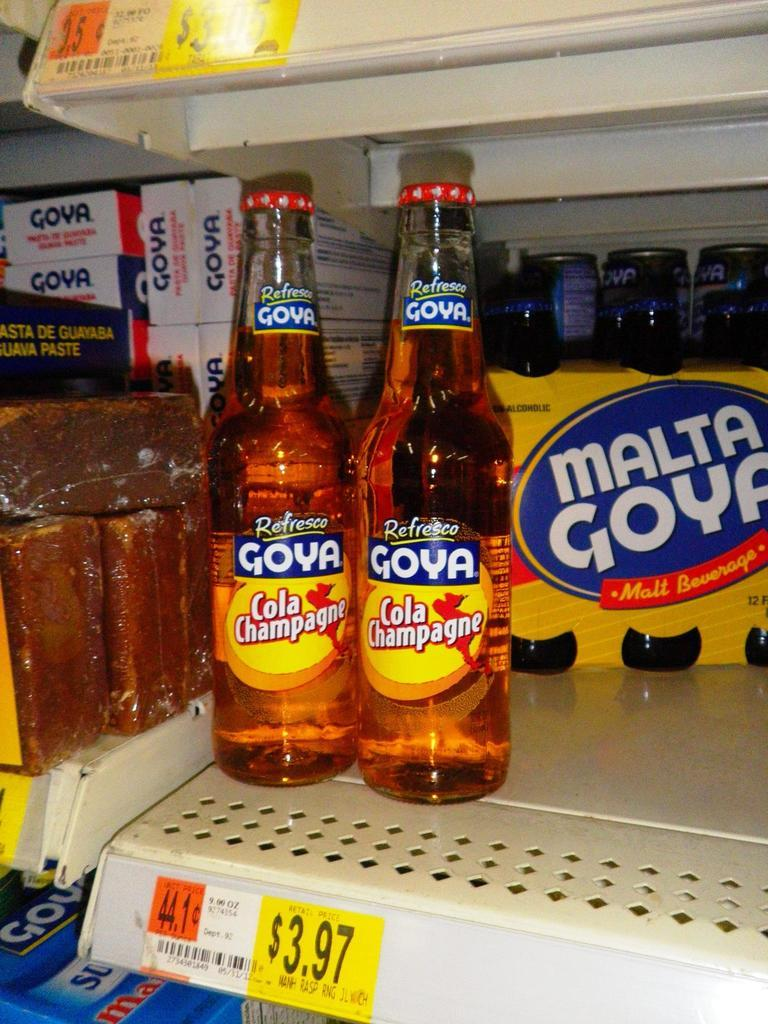Provide a one-sentence caption for the provided image. Two cola champagne bottles made by Refresco Goya sit at the store. 